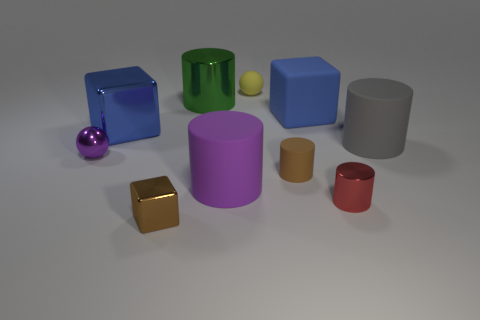There is a purple thing that is to the right of the purple shiny object to the left of the purple object on the right side of the purple metallic sphere; how big is it?
Offer a very short reply. Large. What number of other metal spheres are the same size as the purple ball?
Offer a terse response. 0. How many things are either green metal cylinders or metal objects behind the large blue matte object?
Offer a terse response. 1. There is a yellow thing; what shape is it?
Ensure brevity in your answer.  Sphere. Is the small metallic cylinder the same color as the tiny metal cube?
Provide a short and direct response. No. There is a shiny block that is the same size as the green metal thing; what color is it?
Give a very brief answer. Blue. How many brown objects are balls or small rubber things?
Make the answer very short. 1. Is the number of large blue blocks greater than the number of large green things?
Keep it short and to the point. Yes. Do the ball behind the large blue shiny thing and the blue object that is to the left of the brown shiny object have the same size?
Ensure brevity in your answer.  No. The tiny cylinder to the right of the cube on the right side of the tiny cylinder left of the red shiny cylinder is what color?
Give a very brief answer. Red. 